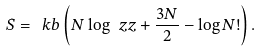<formula> <loc_0><loc_0><loc_500><loc_500>S = \ k b \left ( N \log \ z z + \frac { 3 N } { 2 } - \log N ! \right ) .</formula> 